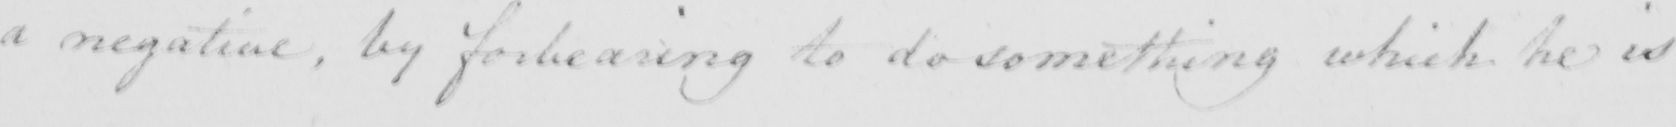What text is written in this handwritten line? a negative , by forbearing to do something which he is 